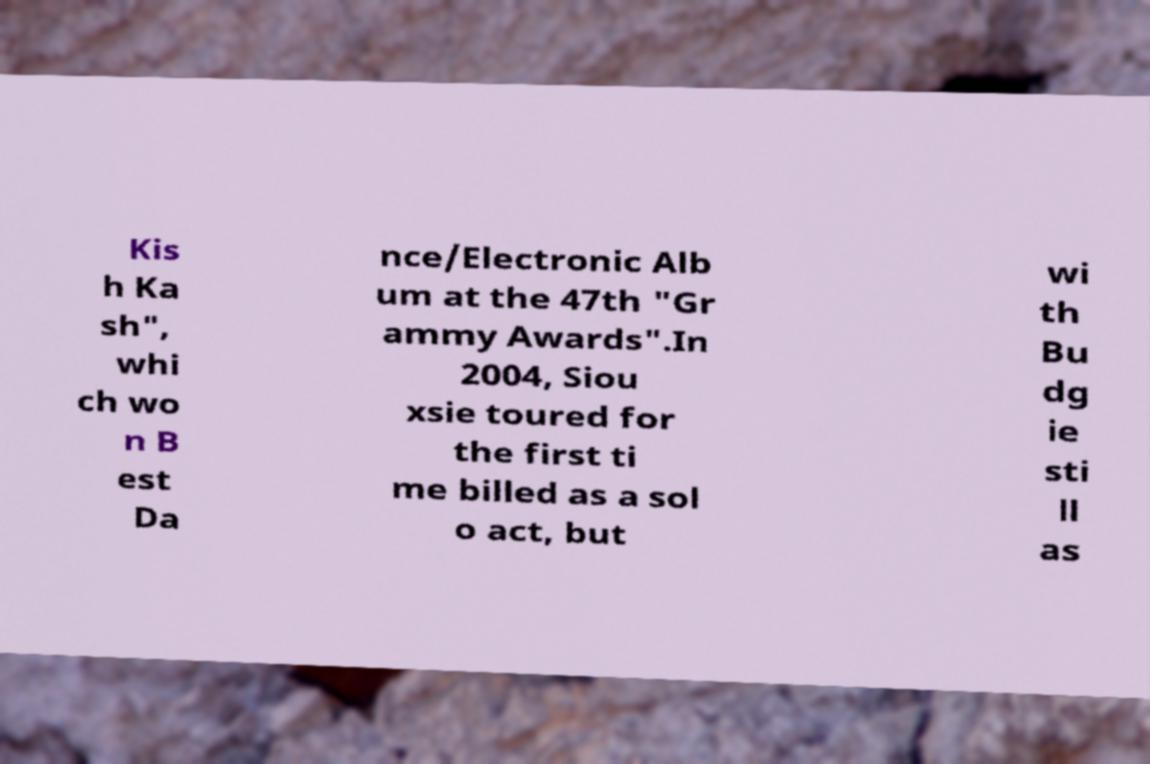There's text embedded in this image that I need extracted. Can you transcribe it verbatim? Kis h Ka sh", whi ch wo n B est Da nce/Electronic Alb um at the 47th "Gr ammy Awards".In 2004, Siou xsie toured for the first ti me billed as a sol o act, but wi th Bu dg ie sti ll as 